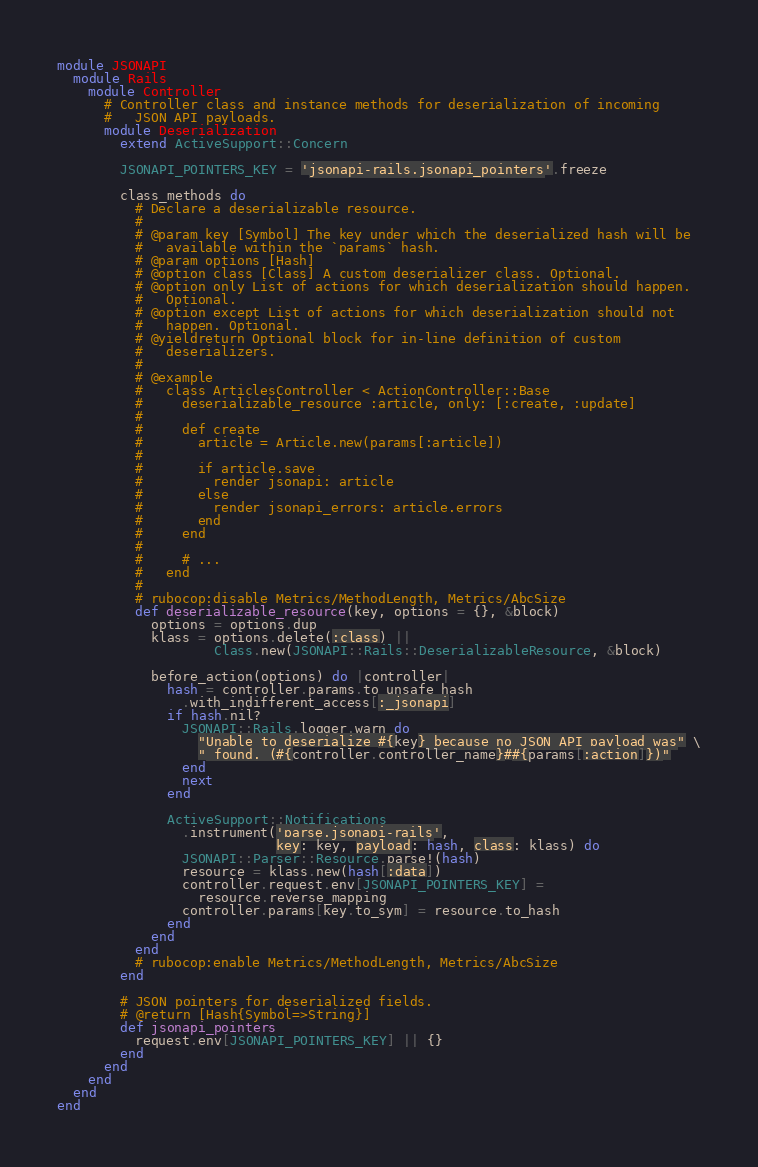Convert code to text. <code><loc_0><loc_0><loc_500><loc_500><_Ruby_>module JSONAPI
  module Rails
    module Controller
      # Controller class and instance methods for deserialization of incoming
      #   JSON API payloads.
      module Deserialization
        extend ActiveSupport::Concern

        JSONAPI_POINTERS_KEY = 'jsonapi-rails.jsonapi_pointers'.freeze

        class_methods do
          # Declare a deserializable resource.
          #
          # @param key [Symbol] The key under which the deserialized hash will be
          #   available within the `params` hash.
          # @param options [Hash]
          # @option class [Class] A custom deserializer class. Optional.
          # @option only List of actions for which deserialization should happen.
          #   Optional.
          # @option except List of actions for which deserialization should not
          #   happen. Optional.
          # @yieldreturn Optional block for in-line definition of custom
          #   deserializers.
          #
          # @example
          #   class ArticlesController < ActionController::Base
          #     deserializable_resource :article, only: [:create, :update]
          #
          #     def create
          #       article = Article.new(params[:article])
          #
          #       if article.save
          #         render jsonapi: article
          #       else
          #         render jsonapi_errors: article.errors
          #       end
          #     end
          #
          #     # ...
          #   end
          #
          # rubocop:disable Metrics/MethodLength, Metrics/AbcSize
          def deserializable_resource(key, options = {}, &block)
            options = options.dup
            klass = options.delete(:class) ||
                    Class.new(JSONAPI::Rails::DeserializableResource, &block)

            before_action(options) do |controller|
              hash = controller.params.to_unsafe_hash
                .with_indifferent_access[:_jsonapi]
              if hash.nil?
                JSONAPI::Rails.logger.warn do
                  "Unable to deserialize #{key} because no JSON API payload was" \
                  " found. (#{controller.controller_name}##{params[:action]})"
                end
                next
              end

              ActiveSupport::Notifications
                .instrument('parse.jsonapi-rails',
                            key: key, payload: hash, class: klass) do
                JSONAPI::Parser::Resource.parse!(hash)
                resource = klass.new(hash[:data])
                controller.request.env[JSONAPI_POINTERS_KEY] =
                  resource.reverse_mapping
                controller.params[key.to_sym] = resource.to_hash
              end
            end
          end
          # rubocop:enable Metrics/MethodLength, Metrics/AbcSize
        end

        # JSON pointers for deserialized fields.
        # @return [Hash{Symbol=>String}]
        def jsonapi_pointers
          request.env[JSONAPI_POINTERS_KEY] || {}
        end
      end
    end
  end
end
</code> 